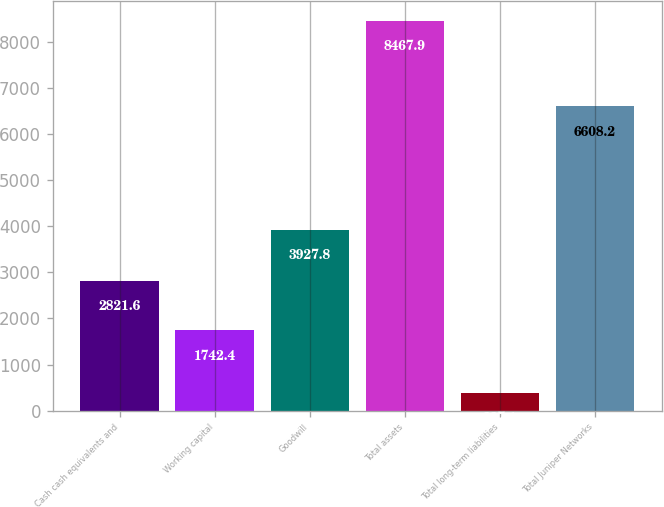Convert chart. <chart><loc_0><loc_0><loc_500><loc_500><bar_chart><fcel>Cash cash equivalents and<fcel>Working capital<fcel>Goodwill<fcel>Total assets<fcel>Total long-term liabilities<fcel>Total Juniper Networks<nl><fcel>2821.6<fcel>1742.4<fcel>3927.8<fcel>8467.9<fcel>387.1<fcel>6608.2<nl></chart> 